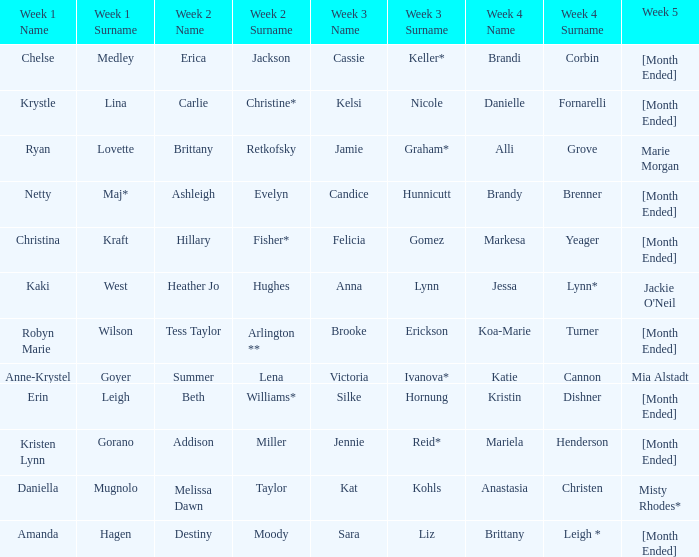What is the week 3 with addison miller in week 2? Jennie Reid*. 